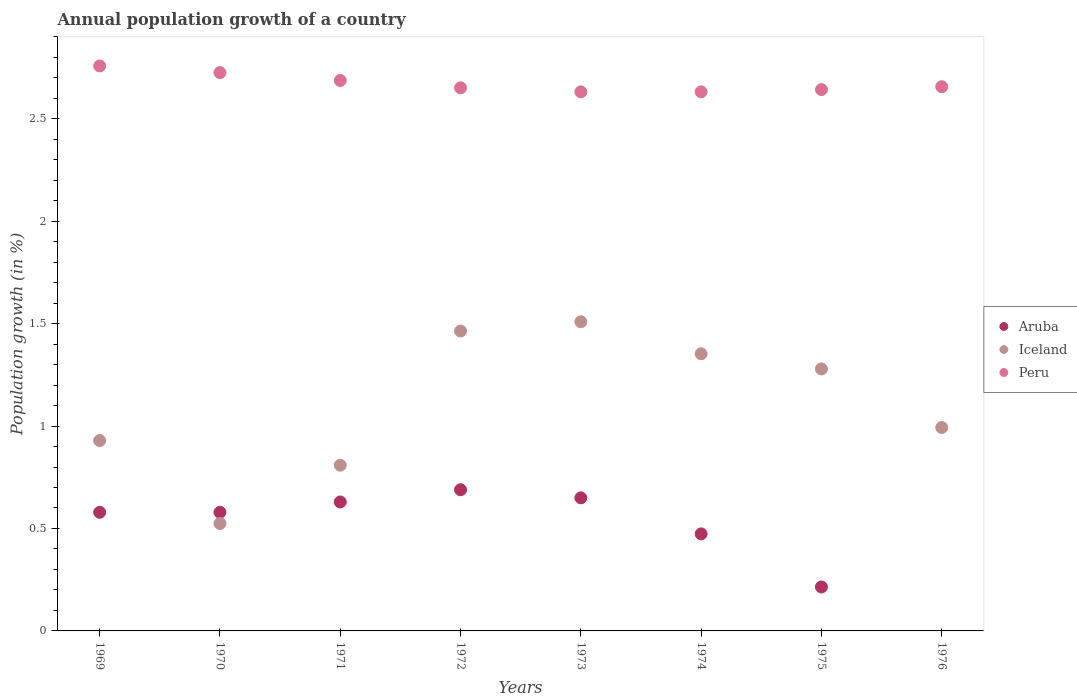Is the number of dotlines equal to the number of legend labels?
Your answer should be compact. No. What is the annual population growth in Peru in 1971?
Offer a terse response. 2.69. Across all years, what is the maximum annual population growth in Aruba?
Your answer should be very brief. 0.69. Across all years, what is the minimum annual population growth in Peru?
Keep it short and to the point. 2.63. In which year was the annual population growth in Peru maximum?
Your answer should be very brief. 1969. What is the total annual population growth in Aruba in the graph?
Offer a very short reply. 3.81. What is the difference between the annual population growth in Iceland in 1969 and that in 1972?
Your answer should be very brief. -0.53. What is the difference between the annual population growth in Aruba in 1975 and the annual population growth in Iceland in 1972?
Provide a succinct answer. -1.25. What is the average annual population growth in Peru per year?
Provide a short and direct response. 2.67. In the year 1975, what is the difference between the annual population growth in Aruba and annual population growth in Peru?
Keep it short and to the point. -2.43. In how many years, is the annual population growth in Aruba greater than 2.1 %?
Offer a very short reply. 0. What is the ratio of the annual population growth in Aruba in 1972 to that in 1974?
Your answer should be compact. 1.45. Is the annual population growth in Aruba in 1971 less than that in 1972?
Offer a very short reply. Yes. Is the difference between the annual population growth in Aruba in 1971 and 1974 greater than the difference between the annual population growth in Peru in 1971 and 1974?
Keep it short and to the point. Yes. What is the difference between the highest and the second highest annual population growth in Peru?
Offer a terse response. 0.03. What is the difference between the highest and the lowest annual population growth in Peru?
Make the answer very short. 0.13. Is the sum of the annual population growth in Iceland in 1975 and 1976 greater than the maximum annual population growth in Aruba across all years?
Your response must be concise. Yes. Is it the case that in every year, the sum of the annual population growth in Aruba and annual population growth in Iceland  is greater than the annual population growth in Peru?
Provide a succinct answer. No. Does the annual population growth in Aruba monotonically increase over the years?
Provide a succinct answer. No. Is the annual population growth in Iceland strictly greater than the annual population growth in Peru over the years?
Provide a succinct answer. No. How many dotlines are there?
Provide a succinct answer. 3. Are the values on the major ticks of Y-axis written in scientific E-notation?
Your answer should be compact. No. Does the graph contain any zero values?
Your response must be concise. Yes. Does the graph contain grids?
Provide a succinct answer. No. What is the title of the graph?
Give a very brief answer. Annual population growth of a country. What is the label or title of the Y-axis?
Provide a succinct answer. Population growth (in %). What is the Population growth (in %) in Aruba in 1969?
Ensure brevity in your answer.  0.58. What is the Population growth (in %) in Iceland in 1969?
Offer a terse response. 0.93. What is the Population growth (in %) in Peru in 1969?
Give a very brief answer. 2.76. What is the Population growth (in %) in Aruba in 1970?
Provide a short and direct response. 0.58. What is the Population growth (in %) in Iceland in 1970?
Offer a very short reply. 0.52. What is the Population growth (in %) of Peru in 1970?
Offer a terse response. 2.72. What is the Population growth (in %) in Aruba in 1971?
Your answer should be very brief. 0.63. What is the Population growth (in %) in Iceland in 1971?
Offer a very short reply. 0.81. What is the Population growth (in %) of Peru in 1971?
Provide a succinct answer. 2.69. What is the Population growth (in %) of Aruba in 1972?
Make the answer very short. 0.69. What is the Population growth (in %) in Iceland in 1972?
Ensure brevity in your answer.  1.46. What is the Population growth (in %) in Peru in 1972?
Make the answer very short. 2.65. What is the Population growth (in %) in Aruba in 1973?
Your response must be concise. 0.65. What is the Population growth (in %) of Iceland in 1973?
Offer a very short reply. 1.51. What is the Population growth (in %) of Peru in 1973?
Your answer should be very brief. 2.63. What is the Population growth (in %) of Aruba in 1974?
Make the answer very short. 0.47. What is the Population growth (in %) of Iceland in 1974?
Provide a succinct answer. 1.35. What is the Population growth (in %) in Peru in 1974?
Offer a terse response. 2.63. What is the Population growth (in %) in Aruba in 1975?
Your response must be concise. 0.21. What is the Population growth (in %) of Iceland in 1975?
Your answer should be very brief. 1.28. What is the Population growth (in %) of Peru in 1975?
Your answer should be compact. 2.64. What is the Population growth (in %) in Iceland in 1976?
Your response must be concise. 0.99. What is the Population growth (in %) in Peru in 1976?
Provide a short and direct response. 2.66. Across all years, what is the maximum Population growth (in %) of Aruba?
Your answer should be compact. 0.69. Across all years, what is the maximum Population growth (in %) of Iceland?
Your answer should be very brief. 1.51. Across all years, what is the maximum Population growth (in %) of Peru?
Your response must be concise. 2.76. Across all years, what is the minimum Population growth (in %) in Iceland?
Provide a succinct answer. 0.52. Across all years, what is the minimum Population growth (in %) of Peru?
Offer a very short reply. 2.63. What is the total Population growth (in %) in Aruba in the graph?
Your response must be concise. 3.81. What is the total Population growth (in %) of Iceland in the graph?
Make the answer very short. 8.86. What is the total Population growth (in %) in Peru in the graph?
Provide a short and direct response. 21.38. What is the difference between the Population growth (in %) in Aruba in 1969 and that in 1970?
Provide a short and direct response. -0. What is the difference between the Population growth (in %) of Iceland in 1969 and that in 1970?
Give a very brief answer. 0.41. What is the difference between the Population growth (in %) in Peru in 1969 and that in 1970?
Your answer should be very brief. 0.03. What is the difference between the Population growth (in %) of Aruba in 1969 and that in 1971?
Keep it short and to the point. -0.05. What is the difference between the Population growth (in %) in Iceland in 1969 and that in 1971?
Give a very brief answer. 0.12. What is the difference between the Population growth (in %) in Peru in 1969 and that in 1971?
Give a very brief answer. 0.07. What is the difference between the Population growth (in %) in Aruba in 1969 and that in 1972?
Offer a terse response. -0.11. What is the difference between the Population growth (in %) in Iceland in 1969 and that in 1972?
Your response must be concise. -0.53. What is the difference between the Population growth (in %) of Peru in 1969 and that in 1972?
Offer a very short reply. 0.11. What is the difference between the Population growth (in %) in Aruba in 1969 and that in 1973?
Your response must be concise. -0.07. What is the difference between the Population growth (in %) in Iceland in 1969 and that in 1973?
Make the answer very short. -0.58. What is the difference between the Population growth (in %) in Peru in 1969 and that in 1973?
Provide a short and direct response. 0.13. What is the difference between the Population growth (in %) of Aruba in 1969 and that in 1974?
Your answer should be very brief. 0.11. What is the difference between the Population growth (in %) of Iceland in 1969 and that in 1974?
Offer a terse response. -0.42. What is the difference between the Population growth (in %) in Peru in 1969 and that in 1974?
Provide a succinct answer. 0.13. What is the difference between the Population growth (in %) of Aruba in 1969 and that in 1975?
Ensure brevity in your answer.  0.36. What is the difference between the Population growth (in %) in Iceland in 1969 and that in 1975?
Give a very brief answer. -0.35. What is the difference between the Population growth (in %) of Peru in 1969 and that in 1975?
Provide a short and direct response. 0.12. What is the difference between the Population growth (in %) of Iceland in 1969 and that in 1976?
Provide a succinct answer. -0.06. What is the difference between the Population growth (in %) of Peru in 1969 and that in 1976?
Your answer should be compact. 0.1. What is the difference between the Population growth (in %) of Aruba in 1970 and that in 1971?
Offer a very short reply. -0.05. What is the difference between the Population growth (in %) in Iceland in 1970 and that in 1971?
Make the answer very short. -0.28. What is the difference between the Population growth (in %) of Peru in 1970 and that in 1971?
Give a very brief answer. 0.04. What is the difference between the Population growth (in %) in Aruba in 1970 and that in 1972?
Offer a very short reply. -0.11. What is the difference between the Population growth (in %) in Iceland in 1970 and that in 1972?
Give a very brief answer. -0.94. What is the difference between the Population growth (in %) of Peru in 1970 and that in 1972?
Give a very brief answer. 0.07. What is the difference between the Population growth (in %) in Aruba in 1970 and that in 1973?
Your answer should be very brief. -0.07. What is the difference between the Population growth (in %) in Iceland in 1970 and that in 1973?
Ensure brevity in your answer.  -0.98. What is the difference between the Population growth (in %) of Peru in 1970 and that in 1973?
Your answer should be compact. 0.09. What is the difference between the Population growth (in %) of Aruba in 1970 and that in 1974?
Your response must be concise. 0.11. What is the difference between the Population growth (in %) of Iceland in 1970 and that in 1974?
Offer a terse response. -0.83. What is the difference between the Population growth (in %) in Peru in 1970 and that in 1974?
Provide a short and direct response. 0.09. What is the difference between the Population growth (in %) in Aruba in 1970 and that in 1975?
Your answer should be very brief. 0.36. What is the difference between the Population growth (in %) in Iceland in 1970 and that in 1975?
Offer a terse response. -0.75. What is the difference between the Population growth (in %) of Peru in 1970 and that in 1975?
Your answer should be very brief. 0.08. What is the difference between the Population growth (in %) of Iceland in 1970 and that in 1976?
Ensure brevity in your answer.  -0.47. What is the difference between the Population growth (in %) in Peru in 1970 and that in 1976?
Your answer should be very brief. 0.07. What is the difference between the Population growth (in %) in Aruba in 1971 and that in 1972?
Make the answer very short. -0.06. What is the difference between the Population growth (in %) of Iceland in 1971 and that in 1972?
Give a very brief answer. -0.66. What is the difference between the Population growth (in %) in Peru in 1971 and that in 1972?
Make the answer very short. 0.04. What is the difference between the Population growth (in %) of Aruba in 1971 and that in 1973?
Your response must be concise. -0.02. What is the difference between the Population growth (in %) of Iceland in 1971 and that in 1973?
Your answer should be very brief. -0.7. What is the difference between the Population growth (in %) in Peru in 1971 and that in 1973?
Make the answer very short. 0.06. What is the difference between the Population growth (in %) of Aruba in 1971 and that in 1974?
Your response must be concise. 0.16. What is the difference between the Population growth (in %) of Iceland in 1971 and that in 1974?
Give a very brief answer. -0.54. What is the difference between the Population growth (in %) of Peru in 1971 and that in 1974?
Your answer should be compact. 0.06. What is the difference between the Population growth (in %) of Aruba in 1971 and that in 1975?
Keep it short and to the point. 0.41. What is the difference between the Population growth (in %) of Iceland in 1971 and that in 1975?
Provide a short and direct response. -0.47. What is the difference between the Population growth (in %) of Peru in 1971 and that in 1975?
Your answer should be compact. 0.04. What is the difference between the Population growth (in %) in Iceland in 1971 and that in 1976?
Your answer should be compact. -0.18. What is the difference between the Population growth (in %) in Peru in 1971 and that in 1976?
Give a very brief answer. 0.03. What is the difference between the Population growth (in %) of Aruba in 1972 and that in 1973?
Ensure brevity in your answer.  0.04. What is the difference between the Population growth (in %) of Iceland in 1972 and that in 1973?
Ensure brevity in your answer.  -0.05. What is the difference between the Population growth (in %) in Peru in 1972 and that in 1973?
Your answer should be compact. 0.02. What is the difference between the Population growth (in %) in Aruba in 1972 and that in 1974?
Provide a succinct answer. 0.22. What is the difference between the Population growth (in %) in Iceland in 1972 and that in 1974?
Your answer should be very brief. 0.11. What is the difference between the Population growth (in %) in Peru in 1972 and that in 1974?
Give a very brief answer. 0.02. What is the difference between the Population growth (in %) of Aruba in 1972 and that in 1975?
Your answer should be compact. 0.47. What is the difference between the Population growth (in %) of Iceland in 1972 and that in 1975?
Your response must be concise. 0.18. What is the difference between the Population growth (in %) in Peru in 1972 and that in 1975?
Ensure brevity in your answer.  0.01. What is the difference between the Population growth (in %) of Iceland in 1972 and that in 1976?
Your answer should be compact. 0.47. What is the difference between the Population growth (in %) of Peru in 1972 and that in 1976?
Give a very brief answer. -0.01. What is the difference between the Population growth (in %) in Aruba in 1973 and that in 1974?
Provide a short and direct response. 0.18. What is the difference between the Population growth (in %) of Iceland in 1973 and that in 1974?
Make the answer very short. 0.16. What is the difference between the Population growth (in %) in Peru in 1973 and that in 1974?
Offer a very short reply. -0. What is the difference between the Population growth (in %) in Aruba in 1973 and that in 1975?
Your answer should be compact. 0.43. What is the difference between the Population growth (in %) in Iceland in 1973 and that in 1975?
Your answer should be very brief. 0.23. What is the difference between the Population growth (in %) in Peru in 1973 and that in 1975?
Offer a very short reply. -0.01. What is the difference between the Population growth (in %) of Iceland in 1973 and that in 1976?
Offer a terse response. 0.52. What is the difference between the Population growth (in %) in Peru in 1973 and that in 1976?
Keep it short and to the point. -0.03. What is the difference between the Population growth (in %) of Aruba in 1974 and that in 1975?
Keep it short and to the point. 0.26. What is the difference between the Population growth (in %) in Iceland in 1974 and that in 1975?
Keep it short and to the point. 0.07. What is the difference between the Population growth (in %) of Peru in 1974 and that in 1975?
Offer a very short reply. -0.01. What is the difference between the Population growth (in %) of Iceland in 1974 and that in 1976?
Your answer should be very brief. 0.36. What is the difference between the Population growth (in %) of Peru in 1974 and that in 1976?
Provide a short and direct response. -0.02. What is the difference between the Population growth (in %) of Iceland in 1975 and that in 1976?
Keep it short and to the point. 0.29. What is the difference between the Population growth (in %) of Peru in 1975 and that in 1976?
Your response must be concise. -0.01. What is the difference between the Population growth (in %) in Aruba in 1969 and the Population growth (in %) in Iceland in 1970?
Your response must be concise. 0.05. What is the difference between the Population growth (in %) in Aruba in 1969 and the Population growth (in %) in Peru in 1970?
Ensure brevity in your answer.  -2.15. What is the difference between the Population growth (in %) in Iceland in 1969 and the Population growth (in %) in Peru in 1970?
Provide a succinct answer. -1.8. What is the difference between the Population growth (in %) in Aruba in 1969 and the Population growth (in %) in Iceland in 1971?
Your answer should be very brief. -0.23. What is the difference between the Population growth (in %) of Aruba in 1969 and the Population growth (in %) of Peru in 1971?
Keep it short and to the point. -2.11. What is the difference between the Population growth (in %) of Iceland in 1969 and the Population growth (in %) of Peru in 1971?
Make the answer very short. -1.76. What is the difference between the Population growth (in %) of Aruba in 1969 and the Population growth (in %) of Iceland in 1972?
Provide a short and direct response. -0.88. What is the difference between the Population growth (in %) in Aruba in 1969 and the Population growth (in %) in Peru in 1972?
Give a very brief answer. -2.07. What is the difference between the Population growth (in %) in Iceland in 1969 and the Population growth (in %) in Peru in 1972?
Your answer should be compact. -1.72. What is the difference between the Population growth (in %) in Aruba in 1969 and the Population growth (in %) in Iceland in 1973?
Offer a very short reply. -0.93. What is the difference between the Population growth (in %) of Aruba in 1969 and the Population growth (in %) of Peru in 1973?
Provide a succinct answer. -2.05. What is the difference between the Population growth (in %) in Iceland in 1969 and the Population growth (in %) in Peru in 1973?
Your response must be concise. -1.7. What is the difference between the Population growth (in %) in Aruba in 1969 and the Population growth (in %) in Iceland in 1974?
Offer a terse response. -0.77. What is the difference between the Population growth (in %) in Aruba in 1969 and the Population growth (in %) in Peru in 1974?
Keep it short and to the point. -2.05. What is the difference between the Population growth (in %) of Iceland in 1969 and the Population growth (in %) of Peru in 1974?
Provide a succinct answer. -1.7. What is the difference between the Population growth (in %) of Aruba in 1969 and the Population growth (in %) of Peru in 1975?
Ensure brevity in your answer.  -2.06. What is the difference between the Population growth (in %) of Iceland in 1969 and the Population growth (in %) of Peru in 1975?
Your answer should be very brief. -1.71. What is the difference between the Population growth (in %) of Aruba in 1969 and the Population growth (in %) of Iceland in 1976?
Offer a terse response. -0.41. What is the difference between the Population growth (in %) of Aruba in 1969 and the Population growth (in %) of Peru in 1976?
Offer a terse response. -2.08. What is the difference between the Population growth (in %) of Iceland in 1969 and the Population growth (in %) of Peru in 1976?
Provide a succinct answer. -1.73. What is the difference between the Population growth (in %) in Aruba in 1970 and the Population growth (in %) in Iceland in 1971?
Give a very brief answer. -0.23. What is the difference between the Population growth (in %) in Aruba in 1970 and the Population growth (in %) in Peru in 1971?
Give a very brief answer. -2.11. What is the difference between the Population growth (in %) in Iceland in 1970 and the Population growth (in %) in Peru in 1971?
Offer a terse response. -2.16. What is the difference between the Population growth (in %) in Aruba in 1970 and the Population growth (in %) in Iceland in 1972?
Provide a short and direct response. -0.88. What is the difference between the Population growth (in %) of Aruba in 1970 and the Population growth (in %) of Peru in 1972?
Provide a short and direct response. -2.07. What is the difference between the Population growth (in %) in Iceland in 1970 and the Population growth (in %) in Peru in 1972?
Offer a very short reply. -2.13. What is the difference between the Population growth (in %) of Aruba in 1970 and the Population growth (in %) of Iceland in 1973?
Provide a succinct answer. -0.93. What is the difference between the Population growth (in %) of Aruba in 1970 and the Population growth (in %) of Peru in 1973?
Provide a short and direct response. -2.05. What is the difference between the Population growth (in %) of Iceland in 1970 and the Population growth (in %) of Peru in 1973?
Offer a very short reply. -2.11. What is the difference between the Population growth (in %) of Aruba in 1970 and the Population growth (in %) of Iceland in 1974?
Your answer should be compact. -0.77. What is the difference between the Population growth (in %) of Aruba in 1970 and the Population growth (in %) of Peru in 1974?
Provide a succinct answer. -2.05. What is the difference between the Population growth (in %) of Iceland in 1970 and the Population growth (in %) of Peru in 1974?
Provide a succinct answer. -2.11. What is the difference between the Population growth (in %) of Aruba in 1970 and the Population growth (in %) of Iceland in 1975?
Your answer should be compact. -0.7. What is the difference between the Population growth (in %) in Aruba in 1970 and the Population growth (in %) in Peru in 1975?
Provide a succinct answer. -2.06. What is the difference between the Population growth (in %) of Iceland in 1970 and the Population growth (in %) of Peru in 1975?
Provide a short and direct response. -2.12. What is the difference between the Population growth (in %) of Aruba in 1970 and the Population growth (in %) of Iceland in 1976?
Offer a very short reply. -0.41. What is the difference between the Population growth (in %) in Aruba in 1970 and the Population growth (in %) in Peru in 1976?
Offer a very short reply. -2.08. What is the difference between the Population growth (in %) of Iceland in 1970 and the Population growth (in %) of Peru in 1976?
Provide a succinct answer. -2.13. What is the difference between the Population growth (in %) of Aruba in 1971 and the Population growth (in %) of Iceland in 1972?
Provide a short and direct response. -0.83. What is the difference between the Population growth (in %) in Aruba in 1971 and the Population growth (in %) in Peru in 1972?
Your answer should be very brief. -2.02. What is the difference between the Population growth (in %) in Iceland in 1971 and the Population growth (in %) in Peru in 1972?
Your response must be concise. -1.84. What is the difference between the Population growth (in %) in Aruba in 1971 and the Population growth (in %) in Iceland in 1973?
Make the answer very short. -0.88. What is the difference between the Population growth (in %) in Aruba in 1971 and the Population growth (in %) in Peru in 1973?
Offer a very short reply. -2. What is the difference between the Population growth (in %) of Iceland in 1971 and the Population growth (in %) of Peru in 1973?
Offer a very short reply. -1.82. What is the difference between the Population growth (in %) of Aruba in 1971 and the Population growth (in %) of Iceland in 1974?
Offer a terse response. -0.72. What is the difference between the Population growth (in %) of Aruba in 1971 and the Population growth (in %) of Peru in 1974?
Offer a very short reply. -2. What is the difference between the Population growth (in %) of Iceland in 1971 and the Population growth (in %) of Peru in 1974?
Make the answer very short. -1.82. What is the difference between the Population growth (in %) of Aruba in 1971 and the Population growth (in %) of Iceland in 1975?
Give a very brief answer. -0.65. What is the difference between the Population growth (in %) of Aruba in 1971 and the Population growth (in %) of Peru in 1975?
Provide a succinct answer. -2.01. What is the difference between the Population growth (in %) in Iceland in 1971 and the Population growth (in %) in Peru in 1975?
Your response must be concise. -1.83. What is the difference between the Population growth (in %) of Aruba in 1971 and the Population growth (in %) of Iceland in 1976?
Your response must be concise. -0.36. What is the difference between the Population growth (in %) in Aruba in 1971 and the Population growth (in %) in Peru in 1976?
Your response must be concise. -2.03. What is the difference between the Population growth (in %) of Iceland in 1971 and the Population growth (in %) of Peru in 1976?
Your response must be concise. -1.85. What is the difference between the Population growth (in %) of Aruba in 1972 and the Population growth (in %) of Iceland in 1973?
Keep it short and to the point. -0.82. What is the difference between the Population growth (in %) of Aruba in 1972 and the Population growth (in %) of Peru in 1973?
Keep it short and to the point. -1.94. What is the difference between the Population growth (in %) of Iceland in 1972 and the Population growth (in %) of Peru in 1973?
Ensure brevity in your answer.  -1.17. What is the difference between the Population growth (in %) of Aruba in 1972 and the Population growth (in %) of Iceland in 1974?
Provide a short and direct response. -0.66. What is the difference between the Population growth (in %) in Aruba in 1972 and the Population growth (in %) in Peru in 1974?
Your answer should be compact. -1.94. What is the difference between the Population growth (in %) of Iceland in 1972 and the Population growth (in %) of Peru in 1974?
Make the answer very short. -1.17. What is the difference between the Population growth (in %) in Aruba in 1972 and the Population growth (in %) in Iceland in 1975?
Offer a very short reply. -0.59. What is the difference between the Population growth (in %) in Aruba in 1972 and the Population growth (in %) in Peru in 1975?
Keep it short and to the point. -1.95. What is the difference between the Population growth (in %) of Iceland in 1972 and the Population growth (in %) of Peru in 1975?
Make the answer very short. -1.18. What is the difference between the Population growth (in %) in Aruba in 1972 and the Population growth (in %) in Iceland in 1976?
Your response must be concise. -0.3. What is the difference between the Population growth (in %) in Aruba in 1972 and the Population growth (in %) in Peru in 1976?
Your answer should be very brief. -1.97. What is the difference between the Population growth (in %) of Iceland in 1972 and the Population growth (in %) of Peru in 1976?
Provide a succinct answer. -1.19. What is the difference between the Population growth (in %) of Aruba in 1973 and the Population growth (in %) of Iceland in 1974?
Provide a succinct answer. -0.7. What is the difference between the Population growth (in %) of Aruba in 1973 and the Population growth (in %) of Peru in 1974?
Provide a succinct answer. -1.98. What is the difference between the Population growth (in %) in Iceland in 1973 and the Population growth (in %) in Peru in 1974?
Offer a terse response. -1.12. What is the difference between the Population growth (in %) in Aruba in 1973 and the Population growth (in %) in Iceland in 1975?
Provide a short and direct response. -0.63. What is the difference between the Population growth (in %) in Aruba in 1973 and the Population growth (in %) in Peru in 1975?
Provide a short and direct response. -1.99. What is the difference between the Population growth (in %) of Iceland in 1973 and the Population growth (in %) of Peru in 1975?
Make the answer very short. -1.13. What is the difference between the Population growth (in %) in Aruba in 1973 and the Population growth (in %) in Iceland in 1976?
Offer a terse response. -0.34. What is the difference between the Population growth (in %) of Aruba in 1973 and the Population growth (in %) of Peru in 1976?
Your answer should be compact. -2.01. What is the difference between the Population growth (in %) of Iceland in 1973 and the Population growth (in %) of Peru in 1976?
Ensure brevity in your answer.  -1.15. What is the difference between the Population growth (in %) of Aruba in 1974 and the Population growth (in %) of Iceland in 1975?
Offer a terse response. -0.81. What is the difference between the Population growth (in %) of Aruba in 1974 and the Population growth (in %) of Peru in 1975?
Keep it short and to the point. -2.17. What is the difference between the Population growth (in %) in Iceland in 1974 and the Population growth (in %) in Peru in 1975?
Your answer should be very brief. -1.29. What is the difference between the Population growth (in %) of Aruba in 1974 and the Population growth (in %) of Iceland in 1976?
Your response must be concise. -0.52. What is the difference between the Population growth (in %) in Aruba in 1974 and the Population growth (in %) in Peru in 1976?
Make the answer very short. -2.18. What is the difference between the Population growth (in %) in Iceland in 1974 and the Population growth (in %) in Peru in 1976?
Make the answer very short. -1.3. What is the difference between the Population growth (in %) in Aruba in 1975 and the Population growth (in %) in Iceland in 1976?
Your answer should be very brief. -0.78. What is the difference between the Population growth (in %) in Aruba in 1975 and the Population growth (in %) in Peru in 1976?
Your answer should be very brief. -2.44. What is the difference between the Population growth (in %) in Iceland in 1975 and the Population growth (in %) in Peru in 1976?
Your answer should be very brief. -1.38. What is the average Population growth (in %) in Aruba per year?
Provide a succinct answer. 0.48. What is the average Population growth (in %) in Iceland per year?
Your answer should be compact. 1.11. What is the average Population growth (in %) in Peru per year?
Give a very brief answer. 2.67. In the year 1969, what is the difference between the Population growth (in %) of Aruba and Population growth (in %) of Iceland?
Offer a terse response. -0.35. In the year 1969, what is the difference between the Population growth (in %) in Aruba and Population growth (in %) in Peru?
Offer a very short reply. -2.18. In the year 1969, what is the difference between the Population growth (in %) of Iceland and Population growth (in %) of Peru?
Your answer should be very brief. -1.83. In the year 1970, what is the difference between the Population growth (in %) in Aruba and Population growth (in %) in Iceland?
Make the answer very short. 0.05. In the year 1970, what is the difference between the Population growth (in %) in Aruba and Population growth (in %) in Peru?
Provide a succinct answer. -2.15. In the year 1970, what is the difference between the Population growth (in %) in Iceland and Population growth (in %) in Peru?
Your answer should be compact. -2.2. In the year 1971, what is the difference between the Population growth (in %) in Aruba and Population growth (in %) in Iceland?
Provide a short and direct response. -0.18. In the year 1971, what is the difference between the Population growth (in %) in Aruba and Population growth (in %) in Peru?
Provide a short and direct response. -2.06. In the year 1971, what is the difference between the Population growth (in %) of Iceland and Population growth (in %) of Peru?
Your response must be concise. -1.88. In the year 1972, what is the difference between the Population growth (in %) of Aruba and Population growth (in %) of Iceland?
Make the answer very short. -0.77. In the year 1972, what is the difference between the Population growth (in %) in Aruba and Population growth (in %) in Peru?
Ensure brevity in your answer.  -1.96. In the year 1972, what is the difference between the Population growth (in %) in Iceland and Population growth (in %) in Peru?
Make the answer very short. -1.19. In the year 1973, what is the difference between the Population growth (in %) in Aruba and Population growth (in %) in Iceland?
Your response must be concise. -0.86. In the year 1973, what is the difference between the Population growth (in %) in Aruba and Population growth (in %) in Peru?
Make the answer very short. -1.98. In the year 1973, what is the difference between the Population growth (in %) of Iceland and Population growth (in %) of Peru?
Your response must be concise. -1.12. In the year 1974, what is the difference between the Population growth (in %) in Aruba and Population growth (in %) in Iceland?
Ensure brevity in your answer.  -0.88. In the year 1974, what is the difference between the Population growth (in %) of Aruba and Population growth (in %) of Peru?
Your answer should be compact. -2.16. In the year 1974, what is the difference between the Population growth (in %) in Iceland and Population growth (in %) in Peru?
Keep it short and to the point. -1.28. In the year 1975, what is the difference between the Population growth (in %) in Aruba and Population growth (in %) in Iceland?
Your answer should be compact. -1.06. In the year 1975, what is the difference between the Population growth (in %) in Aruba and Population growth (in %) in Peru?
Your response must be concise. -2.43. In the year 1975, what is the difference between the Population growth (in %) in Iceland and Population growth (in %) in Peru?
Make the answer very short. -1.36. In the year 1976, what is the difference between the Population growth (in %) of Iceland and Population growth (in %) of Peru?
Make the answer very short. -1.66. What is the ratio of the Population growth (in %) in Aruba in 1969 to that in 1970?
Your answer should be very brief. 1. What is the ratio of the Population growth (in %) of Iceland in 1969 to that in 1970?
Make the answer very short. 1.77. What is the ratio of the Population growth (in %) of Peru in 1969 to that in 1970?
Offer a very short reply. 1.01. What is the ratio of the Population growth (in %) in Aruba in 1969 to that in 1971?
Give a very brief answer. 0.92. What is the ratio of the Population growth (in %) of Iceland in 1969 to that in 1971?
Your answer should be compact. 1.15. What is the ratio of the Population growth (in %) of Peru in 1969 to that in 1971?
Keep it short and to the point. 1.03. What is the ratio of the Population growth (in %) in Aruba in 1969 to that in 1972?
Provide a succinct answer. 0.84. What is the ratio of the Population growth (in %) of Iceland in 1969 to that in 1972?
Your answer should be very brief. 0.63. What is the ratio of the Population growth (in %) of Peru in 1969 to that in 1972?
Offer a terse response. 1.04. What is the ratio of the Population growth (in %) in Aruba in 1969 to that in 1973?
Your answer should be very brief. 0.89. What is the ratio of the Population growth (in %) of Iceland in 1969 to that in 1973?
Your answer should be very brief. 0.62. What is the ratio of the Population growth (in %) of Peru in 1969 to that in 1973?
Your answer should be very brief. 1.05. What is the ratio of the Population growth (in %) of Aruba in 1969 to that in 1974?
Your response must be concise. 1.22. What is the ratio of the Population growth (in %) of Iceland in 1969 to that in 1974?
Offer a very short reply. 0.69. What is the ratio of the Population growth (in %) in Peru in 1969 to that in 1974?
Your response must be concise. 1.05. What is the ratio of the Population growth (in %) of Aruba in 1969 to that in 1975?
Make the answer very short. 2.7. What is the ratio of the Population growth (in %) in Iceland in 1969 to that in 1975?
Offer a very short reply. 0.73. What is the ratio of the Population growth (in %) of Peru in 1969 to that in 1975?
Your answer should be very brief. 1.04. What is the ratio of the Population growth (in %) in Iceland in 1969 to that in 1976?
Your answer should be very brief. 0.94. What is the ratio of the Population growth (in %) of Peru in 1969 to that in 1976?
Provide a short and direct response. 1.04. What is the ratio of the Population growth (in %) of Aruba in 1970 to that in 1971?
Your response must be concise. 0.92. What is the ratio of the Population growth (in %) in Iceland in 1970 to that in 1971?
Offer a terse response. 0.65. What is the ratio of the Population growth (in %) in Peru in 1970 to that in 1971?
Provide a succinct answer. 1.01. What is the ratio of the Population growth (in %) of Aruba in 1970 to that in 1972?
Offer a very short reply. 0.84. What is the ratio of the Population growth (in %) in Iceland in 1970 to that in 1972?
Your response must be concise. 0.36. What is the ratio of the Population growth (in %) of Peru in 1970 to that in 1972?
Your answer should be very brief. 1.03. What is the ratio of the Population growth (in %) in Aruba in 1970 to that in 1973?
Your response must be concise. 0.89. What is the ratio of the Population growth (in %) of Iceland in 1970 to that in 1973?
Make the answer very short. 0.35. What is the ratio of the Population growth (in %) of Peru in 1970 to that in 1973?
Keep it short and to the point. 1.04. What is the ratio of the Population growth (in %) of Aruba in 1970 to that in 1974?
Ensure brevity in your answer.  1.22. What is the ratio of the Population growth (in %) in Iceland in 1970 to that in 1974?
Offer a very short reply. 0.39. What is the ratio of the Population growth (in %) of Peru in 1970 to that in 1974?
Your response must be concise. 1.04. What is the ratio of the Population growth (in %) of Aruba in 1970 to that in 1975?
Provide a succinct answer. 2.7. What is the ratio of the Population growth (in %) in Iceland in 1970 to that in 1975?
Your answer should be very brief. 0.41. What is the ratio of the Population growth (in %) in Peru in 1970 to that in 1975?
Make the answer very short. 1.03. What is the ratio of the Population growth (in %) in Iceland in 1970 to that in 1976?
Give a very brief answer. 0.53. What is the ratio of the Population growth (in %) in Peru in 1970 to that in 1976?
Provide a short and direct response. 1.03. What is the ratio of the Population growth (in %) of Aruba in 1971 to that in 1972?
Ensure brevity in your answer.  0.91. What is the ratio of the Population growth (in %) of Iceland in 1971 to that in 1972?
Your response must be concise. 0.55. What is the ratio of the Population growth (in %) in Peru in 1971 to that in 1972?
Ensure brevity in your answer.  1.01. What is the ratio of the Population growth (in %) of Aruba in 1971 to that in 1973?
Give a very brief answer. 0.97. What is the ratio of the Population growth (in %) in Iceland in 1971 to that in 1973?
Make the answer very short. 0.54. What is the ratio of the Population growth (in %) of Peru in 1971 to that in 1973?
Your answer should be very brief. 1.02. What is the ratio of the Population growth (in %) in Aruba in 1971 to that in 1974?
Your answer should be very brief. 1.33. What is the ratio of the Population growth (in %) of Iceland in 1971 to that in 1974?
Your response must be concise. 0.6. What is the ratio of the Population growth (in %) in Peru in 1971 to that in 1974?
Your response must be concise. 1.02. What is the ratio of the Population growth (in %) in Aruba in 1971 to that in 1975?
Your answer should be compact. 2.93. What is the ratio of the Population growth (in %) of Iceland in 1971 to that in 1975?
Keep it short and to the point. 0.63. What is the ratio of the Population growth (in %) in Peru in 1971 to that in 1975?
Your answer should be very brief. 1.02. What is the ratio of the Population growth (in %) of Iceland in 1971 to that in 1976?
Your answer should be very brief. 0.81. What is the ratio of the Population growth (in %) in Peru in 1971 to that in 1976?
Keep it short and to the point. 1.01. What is the ratio of the Population growth (in %) in Aruba in 1972 to that in 1973?
Your answer should be very brief. 1.06. What is the ratio of the Population growth (in %) in Peru in 1972 to that in 1973?
Give a very brief answer. 1.01. What is the ratio of the Population growth (in %) of Aruba in 1972 to that in 1974?
Offer a terse response. 1.45. What is the ratio of the Population growth (in %) in Iceland in 1972 to that in 1974?
Your answer should be very brief. 1.08. What is the ratio of the Population growth (in %) of Peru in 1972 to that in 1974?
Your response must be concise. 1.01. What is the ratio of the Population growth (in %) in Aruba in 1972 to that in 1975?
Keep it short and to the point. 3.21. What is the ratio of the Population growth (in %) of Iceland in 1972 to that in 1975?
Ensure brevity in your answer.  1.14. What is the ratio of the Population growth (in %) in Iceland in 1972 to that in 1976?
Offer a terse response. 1.47. What is the ratio of the Population growth (in %) of Peru in 1972 to that in 1976?
Your answer should be compact. 1. What is the ratio of the Population growth (in %) in Aruba in 1973 to that in 1974?
Your response must be concise. 1.37. What is the ratio of the Population growth (in %) of Iceland in 1973 to that in 1974?
Offer a terse response. 1.12. What is the ratio of the Population growth (in %) in Peru in 1973 to that in 1974?
Keep it short and to the point. 1. What is the ratio of the Population growth (in %) in Aruba in 1973 to that in 1975?
Make the answer very short. 3.03. What is the ratio of the Population growth (in %) in Iceland in 1973 to that in 1975?
Offer a very short reply. 1.18. What is the ratio of the Population growth (in %) of Iceland in 1973 to that in 1976?
Make the answer very short. 1.52. What is the ratio of the Population growth (in %) in Peru in 1973 to that in 1976?
Your answer should be very brief. 0.99. What is the ratio of the Population growth (in %) in Aruba in 1974 to that in 1975?
Offer a terse response. 2.21. What is the ratio of the Population growth (in %) in Iceland in 1974 to that in 1975?
Your answer should be compact. 1.06. What is the ratio of the Population growth (in %) of Iceland in 1974 to that in 1976?
Provide a short and direct response. 1.36. What is the ratio of the Population growth (in %) of Peru in 1974 to that in 1976?
Offer a terse response. 0.99. What is the ratio of the Population growth (in %) of Iceland in 1975 to that in 1976?
Provide a succinct answer. 1.29. What is the ratio of the Population growth (in %) in Peru in 1975 to that in 1976?
Ensure brevity in your answer.  0.99. What is the difference between the highest and the second highest Population growth (in %) in Aruba?
Offer a very short reply. 0.04. What is the difference between the highest and the second highest Population growth (in %) in Iceland?
Ensure brevity in your answer.  0.05. What is the difference between the highest and the second highest Population growth (in %) of Peru?
Your response must be concise. 0.03. What is the difference between the highest and the lowest Population growth (in %) in Aruba?
Your response must be concise. 0.69. What is the difference between the highest and the lowest Population growth (in %) of Peru?
Give a very brief answer. 0.13. 